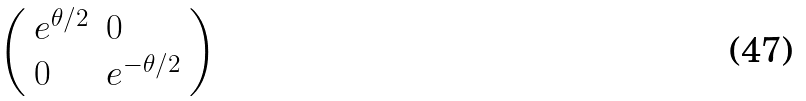Convert formula to latex. <formula><loc_0><loc_0><loc_500><loc_500>\left ( \begin{array} { l l } { e ^ { \theta / 2 } } & { 0 } \\ { 0 } & { e ^ { - \theta / 2 } } \end{array} \right )</formula> 